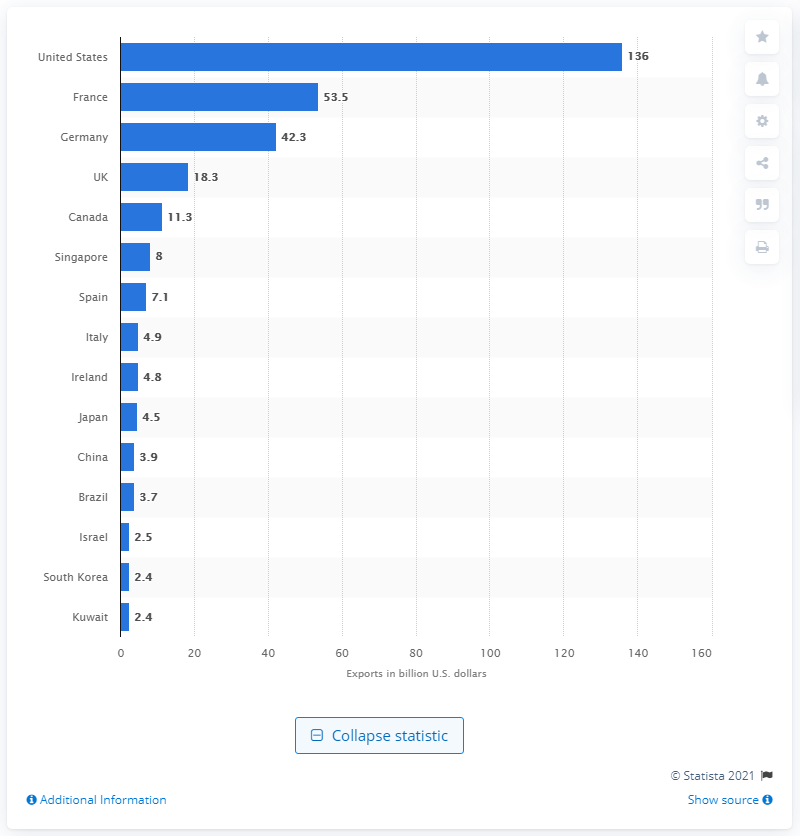List a handful of essential elements in this visual. In 2019, the United States contributed significantly to aerospace exports, totaling $136 million. 